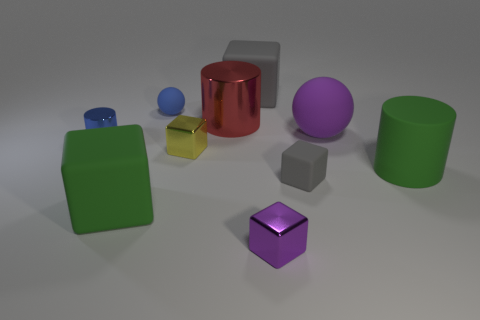Subtract all brown cubes. Subtract all brown spheres. How many cubes are left? 5 Subtract all cylinders. How many objects are left? 7 Add 7 large green rubber blocks. How many large green rubber blocks exist? 8 Subtract 0 green spheres. How many objects are left? 10 Subtract all yellow metal blocks. Subtract all small blue cylinders. How many objects are left? 8 Add 5 big matte balls. How many big matte balls are left? 6 